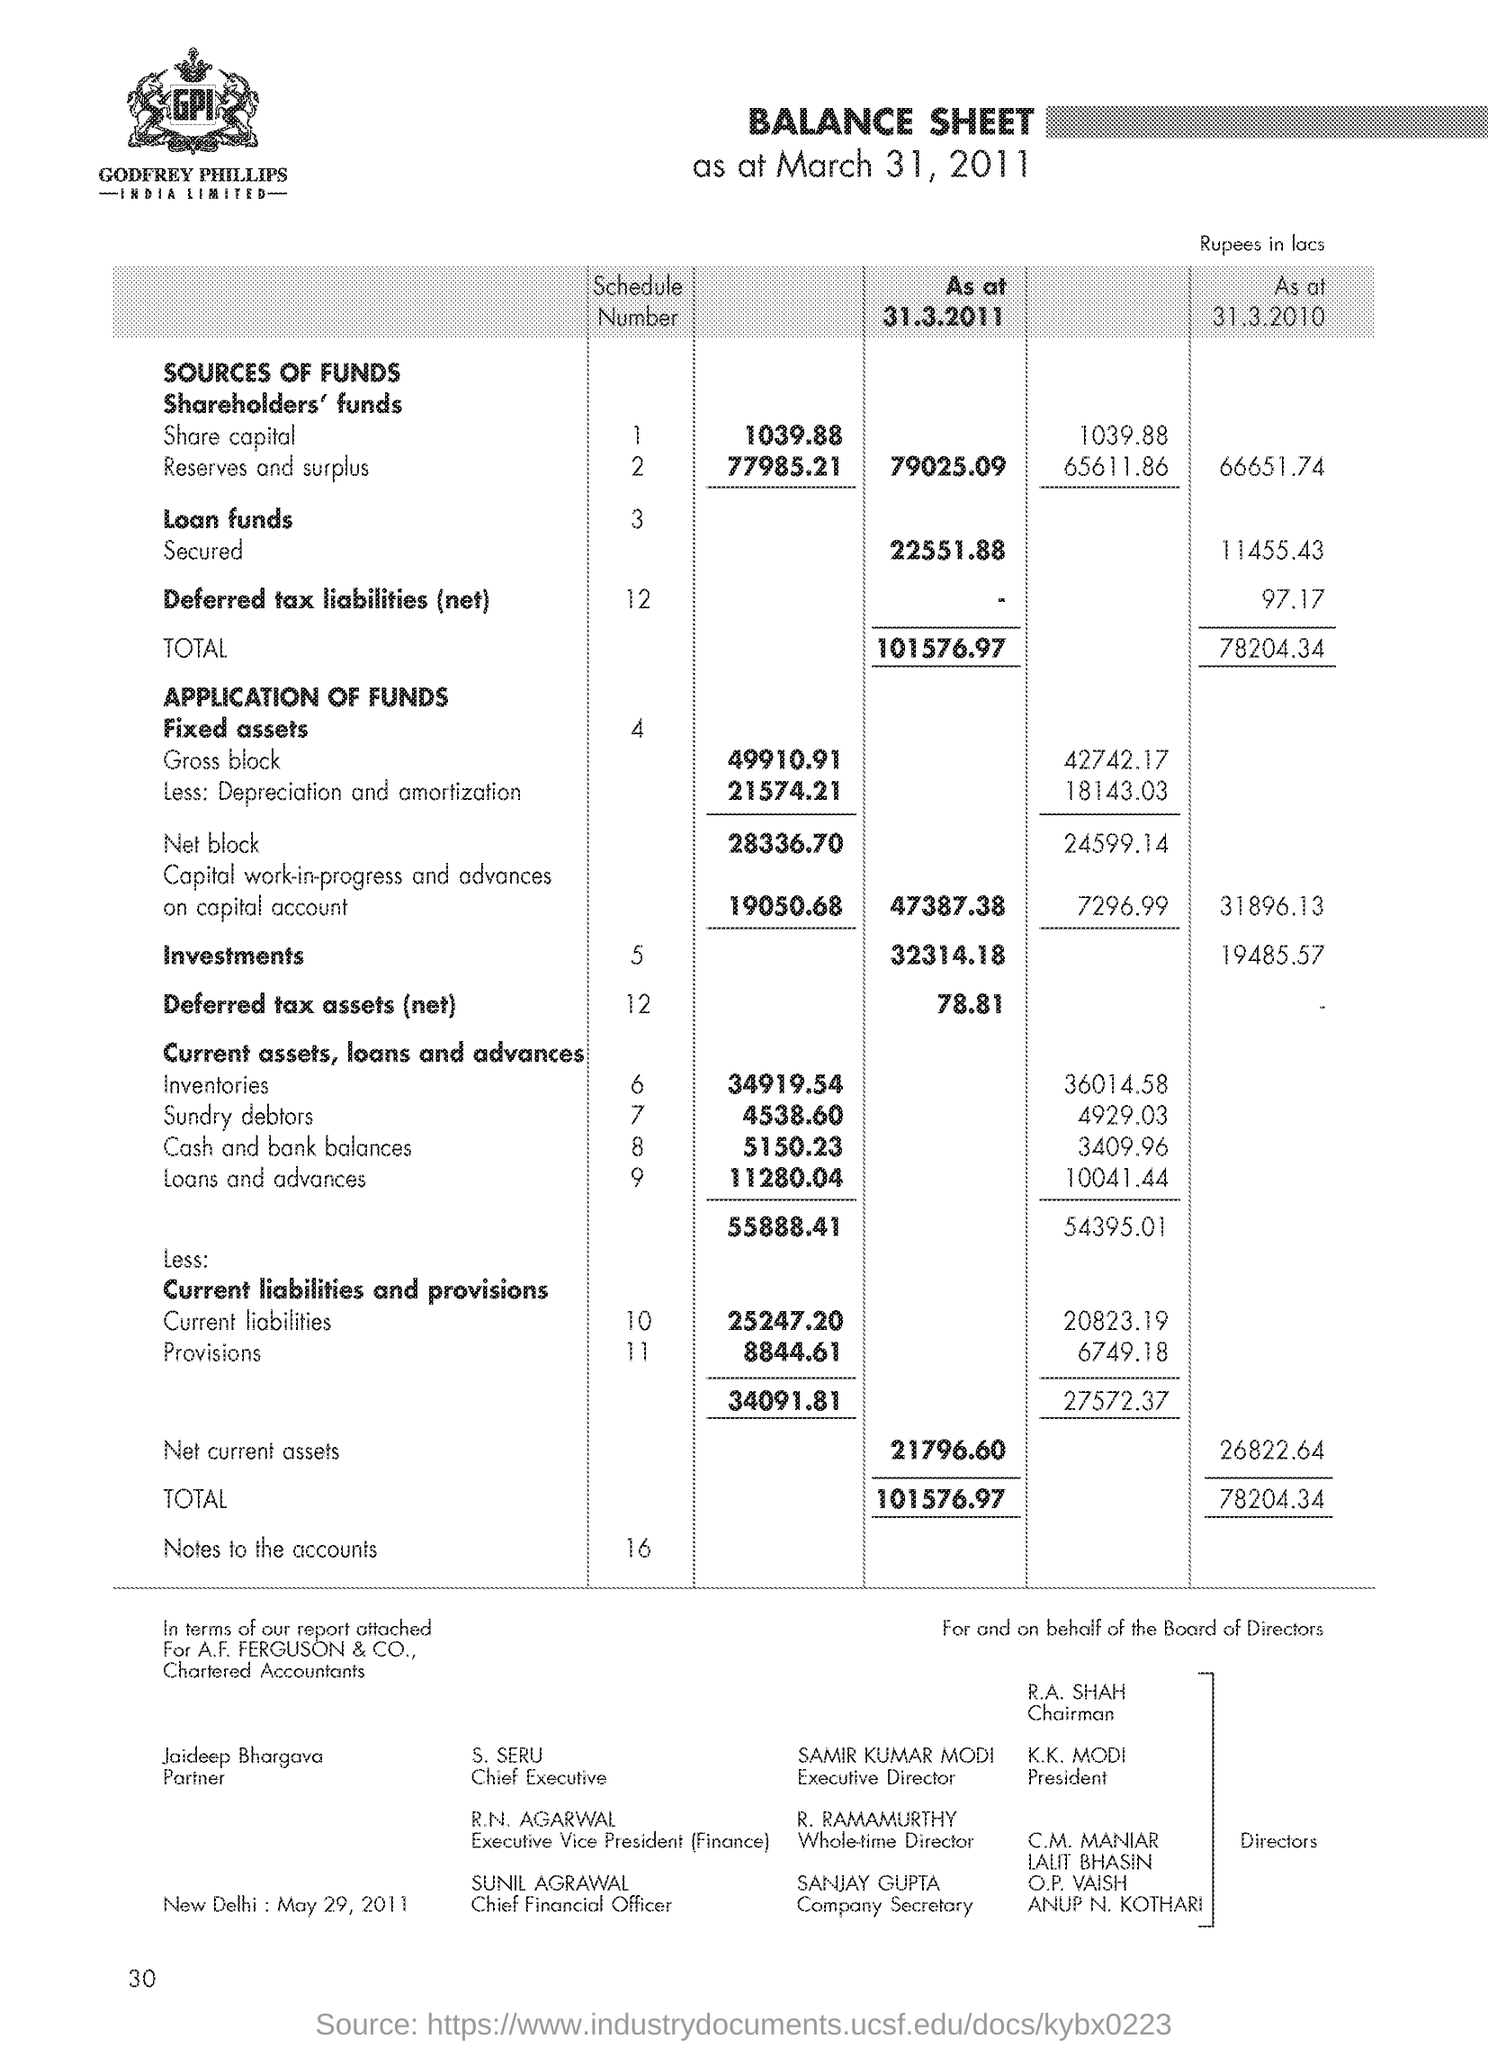Give some essential details in this illustration. R. RAMAMURTHY is the Whole-time Director. As of March 31, 2011, the provisions were 8,844.61. As of March 31, 2010, the value of investments was 19,485.57. Sunil Agrawal is the Chief Financial Officer. The net current assets as at March 31, 2011, were 21,796.60. 